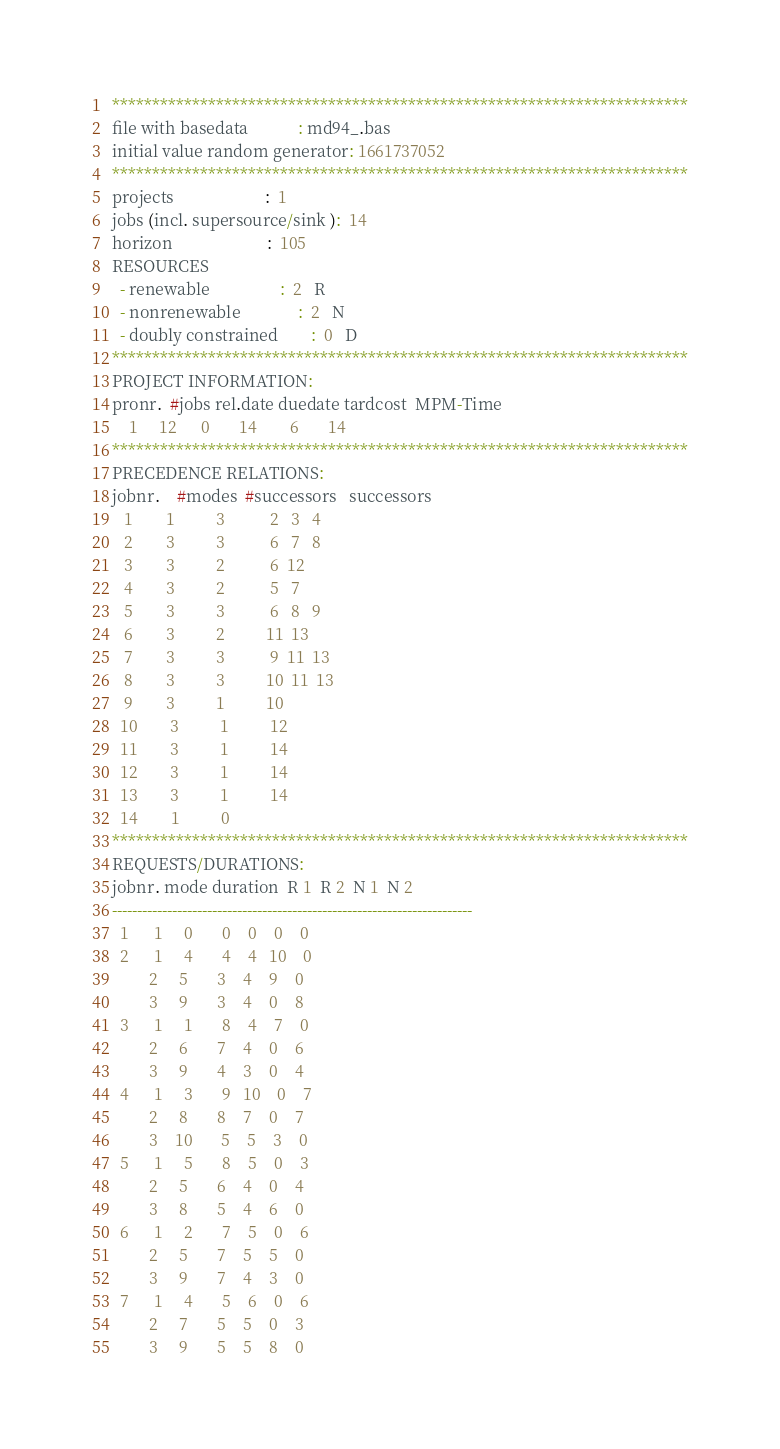Convert code to text. <code><loc_0><loc_0><loc_500><loc_500><_ObjectiveC_>************************************************************************
file with basedata            : md94_.bas
initial value random generator: 1661737052
************************************************************************
projects                      :  1
jobs (incl. supersource/sink ):  14
horizon                       :  105
RESOURCES
  - renewable                 :  2   R
  - nonrenewable              :  2   N
  - doubly constrained        :  0   D
************************************************************************
PROJECT INFORMATION:
pronr.  #jobs rel.date duedate tardcost  MPM-Time
    1     12      0       14        6       14
************************************************************************
PRECEDENCE RELATIONS:
jobnr.    #modes  #successors   successors
   1        1          3           2   3   4
   2        3          3           6   7   8
   3        3          2           6  12
   4        3          2           5   7
   5        3          3           6   8   9
   6        3          2          11  13
   7        3          3           9  11  13
   8        3          3          10  11  13
   9        3          1          10
  10        3          1          12
  11        3          1          14
  12        3          1          14
  13        3          1          14
  14        1          0        
************************************************************************
REQUESTS/DURATIONS:
jobnr. mode duration  R 1  R 2  N 1  N 2
------------------------------------------------------------------------
  1      1     0       0    0    0    0
  2      1     4       4    4   10    0
         2     5       3    4    9    0
         3     9       3    4    0    8
  3      1     1       8    4    7    0
         2     6       7    4    0    6
         3     9       4    3    0    4
  4      1     3       9   10    0    7
         2     8       8    7    0    7
         3    10       5    5    3    0
  5      1     5       8    5    0    3
         2     5       6    4    0    4
         3     8       5    4    6    0
  6      1     2       7    5    0    6
         2     5       7    5    5    0
         3     9       7    4    3    0
  7      1     4       5    6    0    6
         2     7       5    5    0    3
         3     9       5    5    8    0</code> 